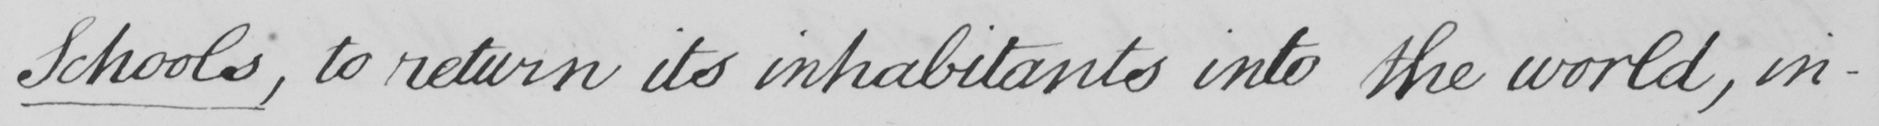Transcribe the text shown in this historical manuscript line. Schools , to return its inhabitants into the world , in- 